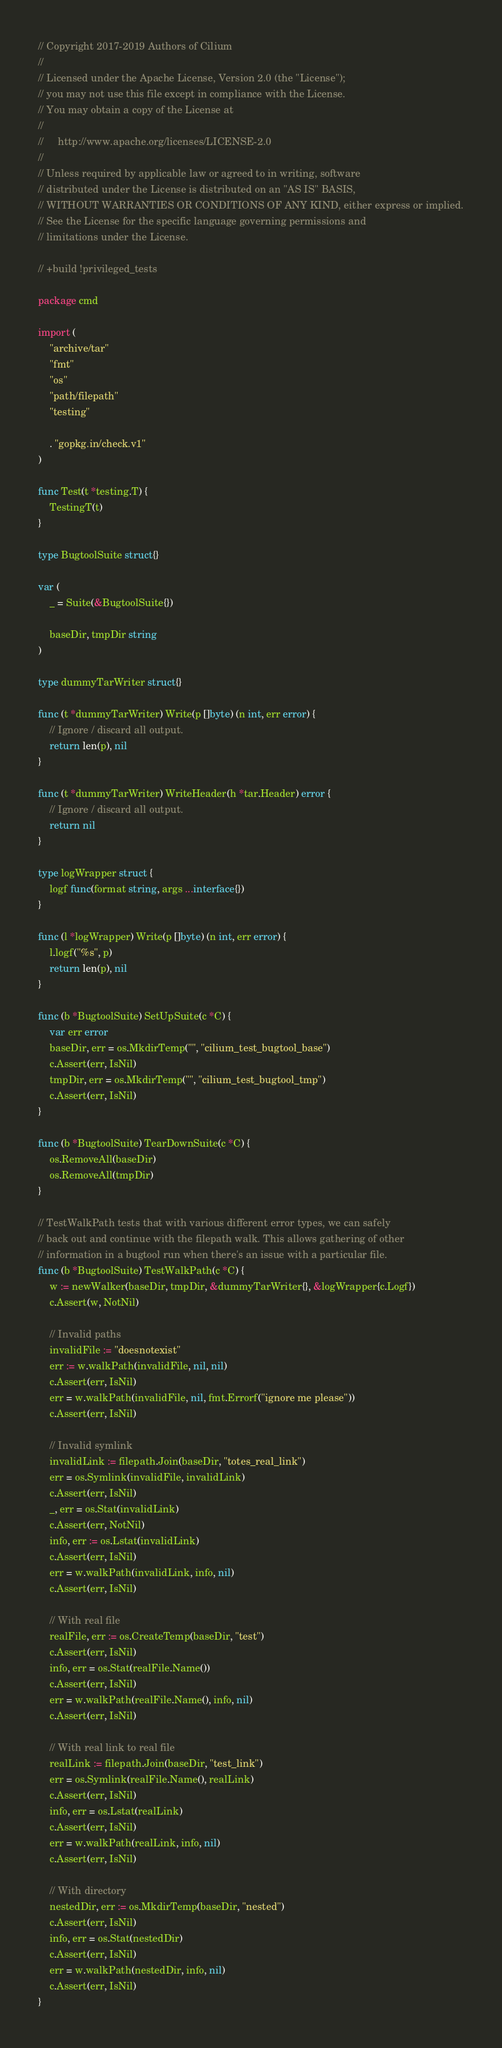<code> <loc_0><loc_0><loc_500><loc_500><_Go_>// Copyright 2017-2019 Authors of Cilium
//
// Licensed under the Apache License, Version 2.0 (the "License");
// you may not use this file except in compliance with the License.
// You may obtain a copy of the License at
//
//     http://www.apache.org/licenses/LICENSE-2.0
//
// Unless required by applicable law or agreed to in writing, software
// distributed under the License is distributed on an "AS IS" BASIS,
// WITHOUT WARRANTIES OR CONDITIONS OF ANY KIND, either express or implied.
// See the License for the specific language governing permissions and
// limitations under the License.

// +build !privileged_tests

package cmd

import (
	"archive/tar"
	"fmt"
	"os"
	"path/filepath"
	"testing"

	. "gopkg.in/check.v1"
)

func Test(t *testing.T) {
	TestingT(t)
}

type BugtoolSuite struct{}

var (
	_ = Suite(&BugtoolSuite{})

	baseDir, tmpDir string
)

type dummyTarWriter struct{}

func (t *dummyTarWriter) Write(p []byte) (n int, err error) {
	// Ignore / discard all output.
	return len(p), nil
}

func (t *dummyTarWriter) WriteHeader(h *tar.Header) error {
	// Ignore / discard all output.
	return nil
}

type logWrapper struct {
	logf func(format string, args ...interface{})
}

func (l *logWrapper) Write(p []byte) (n int, err error) {
	l.logf("%s", p)
	return len(p), nil
}

func (b *BugtoolSuite) SetUpSuite(c *C) {
	var err error
	baseDir, err = os.MkdirTemp("", "cilium_test_bugtool_base")
	c.Assert(err, IsNil)
	tmpDir, err = os.MkdirTemp("", "cilium_test_bugtool_tmp")
	c.Assert(err, IsNil)
}

func (b *BugtoolSuite) TearDownSuite(c *C) {
	os.RemoveAll(baseDir)
	os.RemoveAll(tmpDir)
}

// TestWalkPath tests that with various different error types, we can safely
// back out and continue with the filepath walk. This allows gathering of other
// information in a bugtool run when there's an issue with a particular file.
func (b *BugtoolSuite) TestWalkPath(c *C) {
	w := newWalker(baseDir, tmpDir, &dummyTarWriter{}, &logWrapper{c.Logf})
	c.Assert(w, NotNil)

	// Invalid paths
	invalidFile := "doesnotexist"
	err := w.walkPath(invalidFile, nil, nil)
	c.Assert(err, IsNil)
	err = w.walkPath(invalidFile, nil, fmt.Errorf("ignore me please"))
	c.Assert(err, IsNil)

	// Invalid symlink
	invalidLink := filepath.Join(baseDir, "totes_real_link")
	err = os.Symlink(invalidFile, invalidLink)
	c.Assert(err, IsNil)
	_, err = os.Stat(invalidLink)
	c.Assert(err, NotNil)
	info, err := os.Lstat(invalidLink)
	c.Assert(err, IsNil)
	err = w.walkPath(invalidLink, info, nil)
	c.Assert(err, IsNil)

	// With real file
	realFile, err := os.CreateTemp(baseDir, "test")
	c.Assert(err, IsNil)
	info, err = os.Stat(realFile.Name())
	c.Assert(err, IsNil)
	err = w.walkPath(realFile.Name(), info, nil)
	c.Assert(err, IsNil)

	// With real link to real file
	realLink := filepath.Join(baseDir, "test_link")
	err = os.Symlink(realFile.Name(), realLink)
	c.Assert(err, IsNil)
	info, err = os.Lstat(realLink)
	c.Assert(err, IsNil)
	err = w.walkPath(realLink, info, nil)
	c.Assert(err, IsNil)

	// With directory
	nestedDir, err := os.MkdirTemp(baseDir, "nested")
	c.Assert(err, IsNil)
	info, err = os.Stat(nestedDir)
	c.Assert(err, IsNil)
	err = w.walkPath(nestedDir, info, nil)
	c.Assert(err, IsNil)
}
</code> 